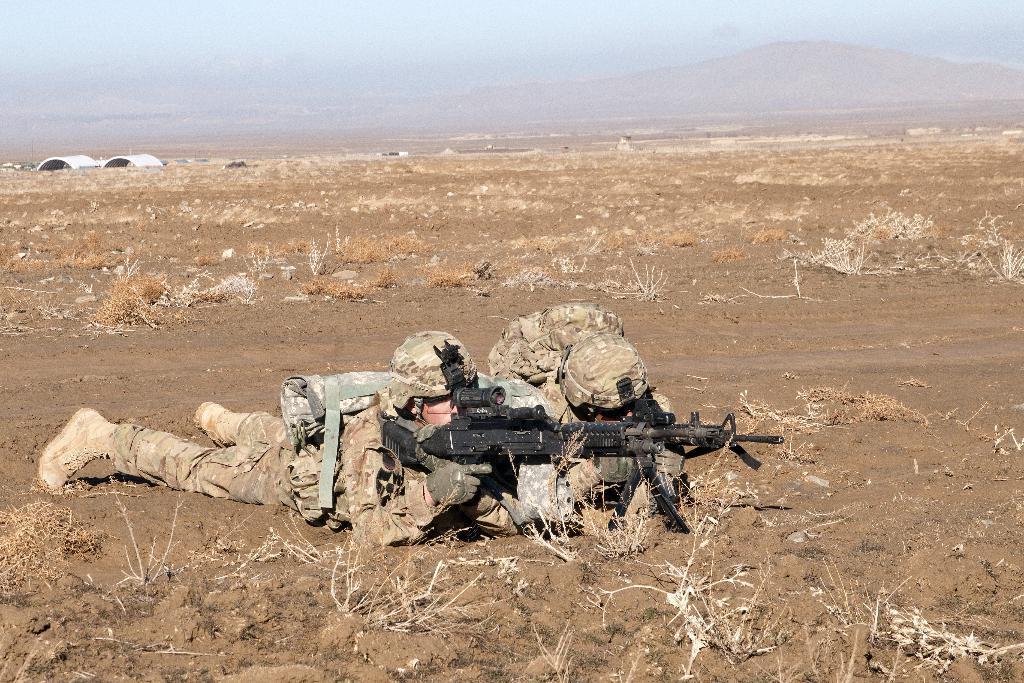Can you describe this image briefly? There are two persons wearing military dress are crawling on the ground and holding a gun in their hands. 